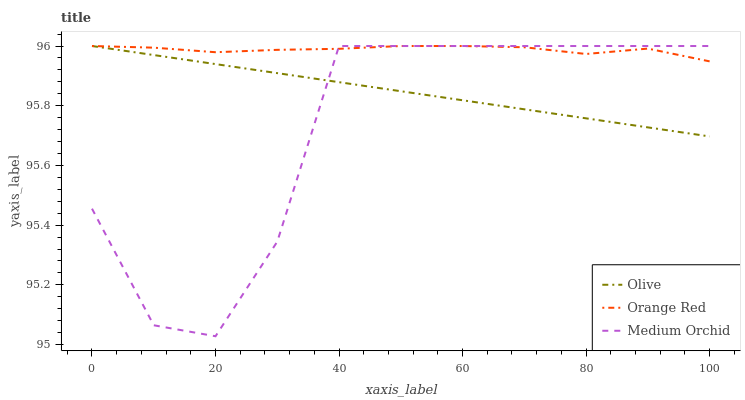Does Medium Orchid have the minimum area under the curve?
Answer yes or no. Yes. Does Orange Red have the maximum area under the curve?
Answer yes or no. Yes. Does Orange Red have the minimum area under the curve?
Answer yes or no. No. Does Medium Orchid have the maximum area under the curve?
Answer yes or no. No. Is Olive the smoothest?
Answer yes or no. Yes. Is Medium Orchid the roughest?
Answer yes or no. Yes. Is Orange Red the smoothest?
Answer yes or no. No. Is Orange Red the roughest?
Answer yes or no. No. Does Orange Red have the lowest value?
Answer yes or no. No. Does Orange Red have the highest value?
Answer yes or no. Yes. Does Medium Orchid intersect Orange Red?
Answer yes or no. Yes. Is Medium Orchid less than Orange Red?
Answer yes or no. No. Is Medium Orchid greater than Orange Red?
Answer yes or no. No. 